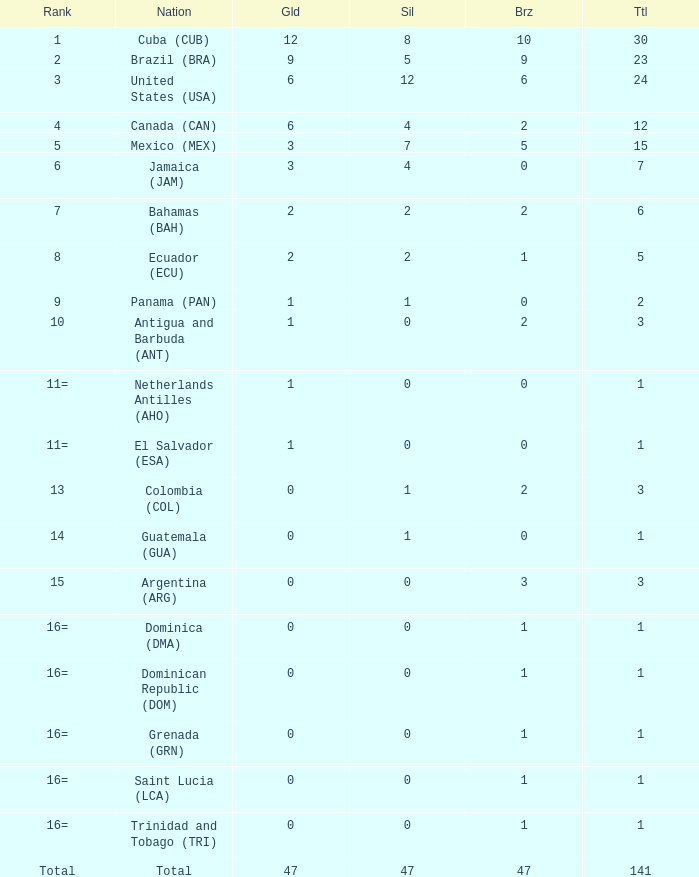What is the total gold with a total less than 1? None. 